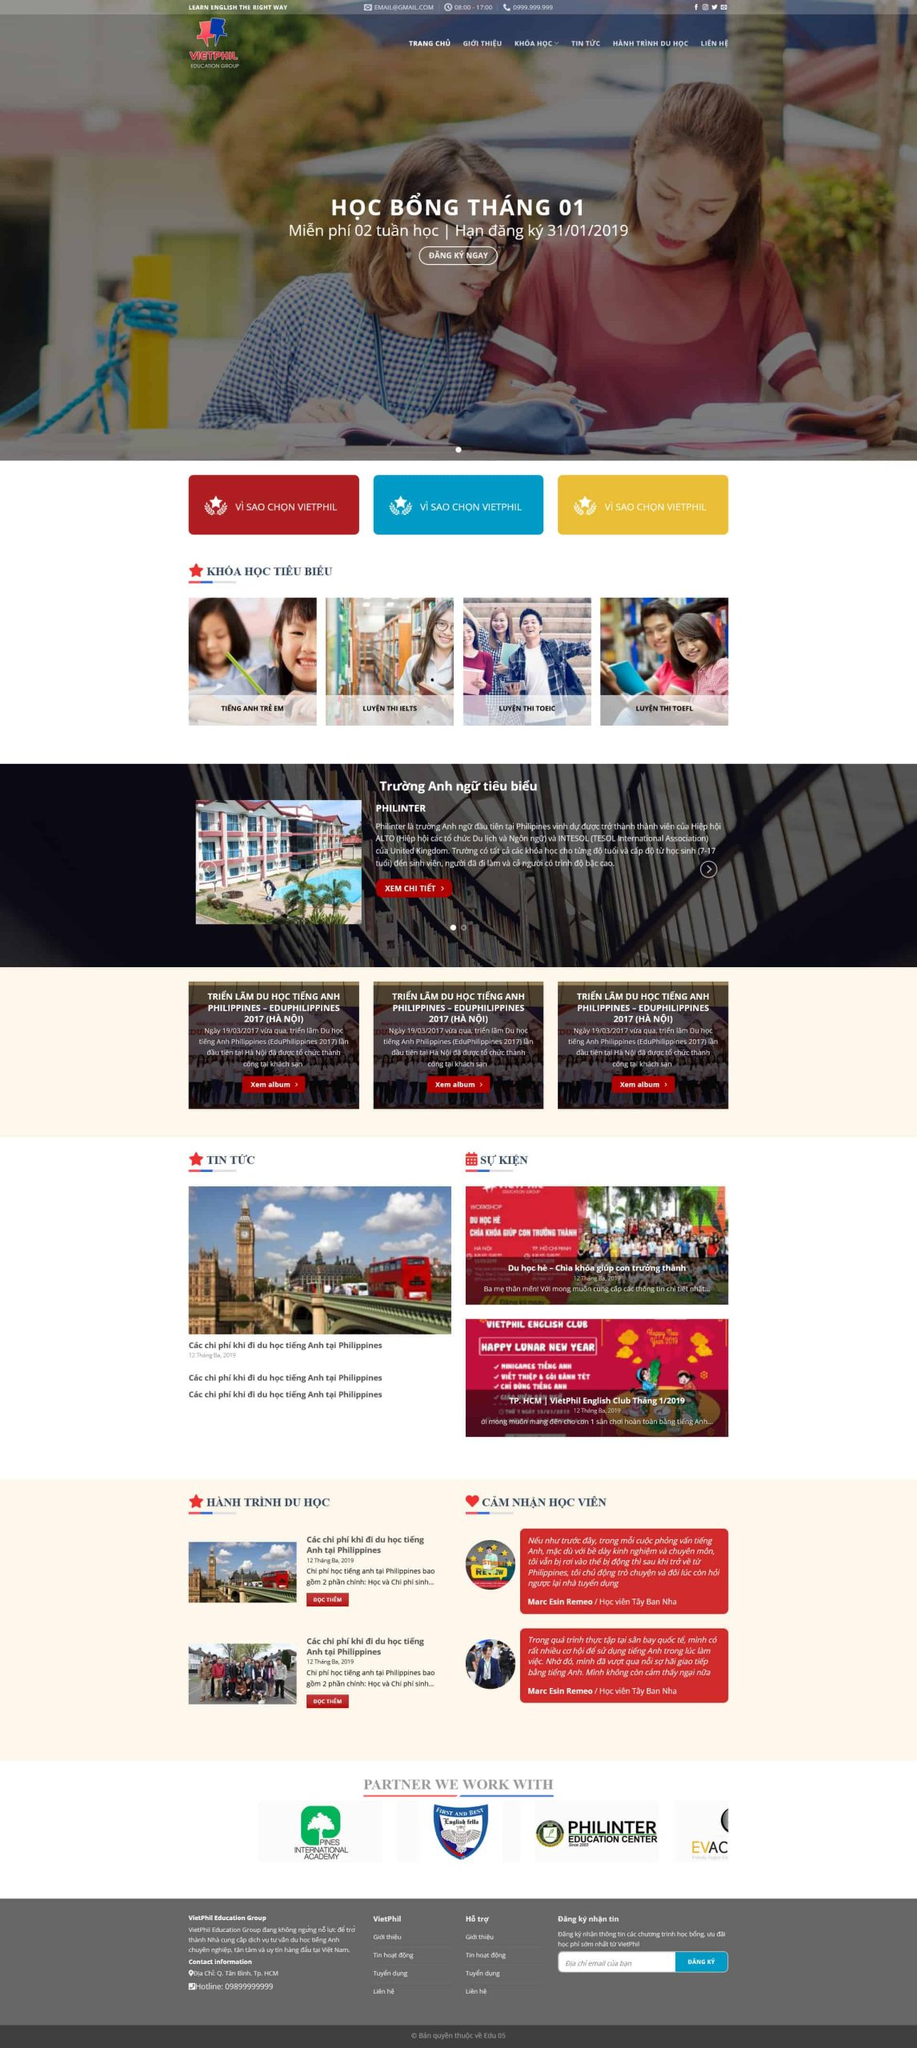Liệt kê 5 ngành nghề, lĩnh vực phù hợp với website này, phân cách các màu sắc bằng dấu phẩy. Chỉ trả về kết quả, phân cách bằng dấy phẩy
 Giáo dục, Đào tạo ngoại ngữ, Du học, Tư vấn giáo dục, Luyện thi quốc tế 